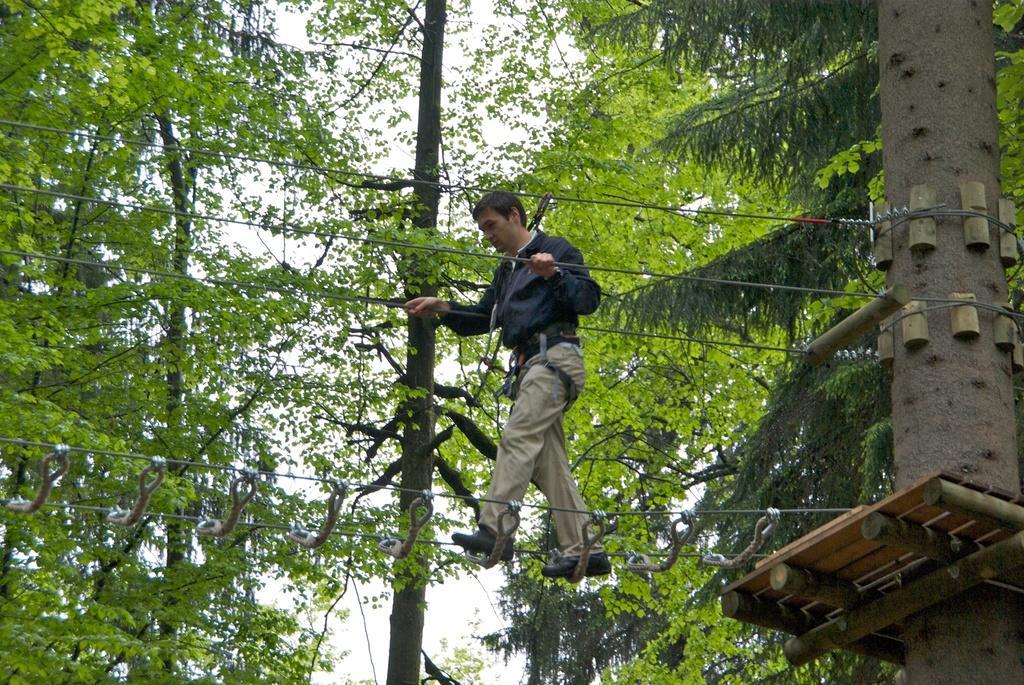Can you describe this image briefly? In this image there is a man who is walking on the rope bridge by holding the ropes which are tied to the tree. On the right side there is a tree. In the background there are trees. 